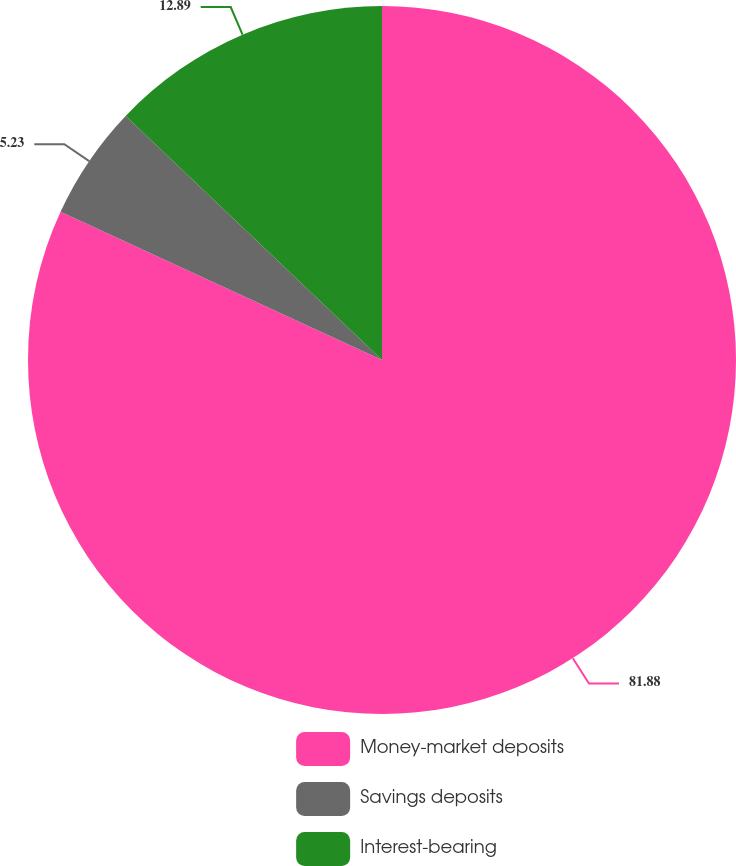Convert chart to OTSL. <chart><loc_0><loc_0><loc_500><loc_500><pie_chart><fcel>Money-market deposits<fcel>Savings deposits<fcel>Interest-bearing<nl><fcel>81.88%<fcel>5.23%<fcel>12.89%<nl></chart> 